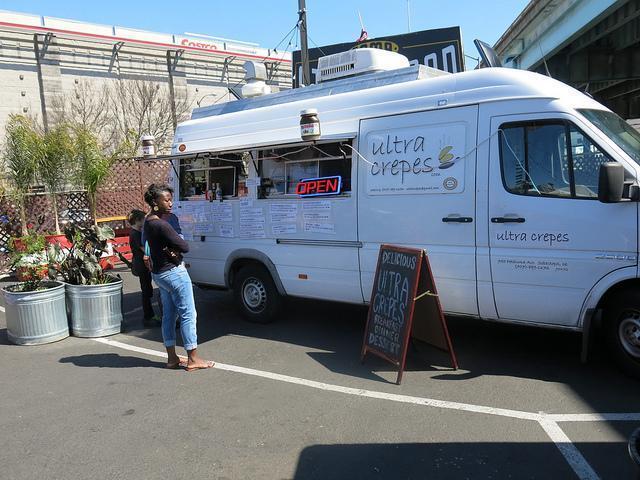How many potted plants are visible?
Give a very brief answer. 2. How many kids are holding a laptop on their lap ?
Give a very brief answer. 0. 